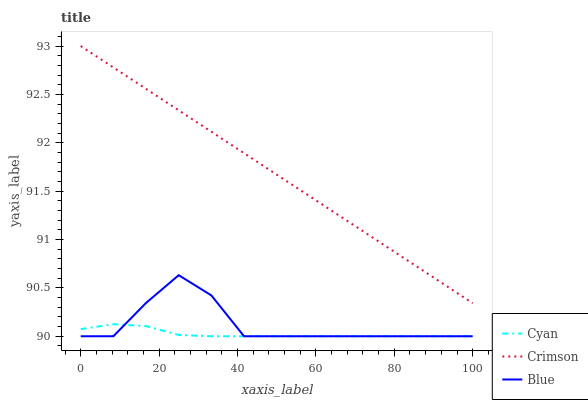Does Cyan have the minimum area under the curve?
Answer yes or no. Yes. Does Crimson have the maximum area under the curve?
Answer yes or no. Yes. Does Blue have the minimum area under the curve?
Answer yes or no. No. Does Blue have the maximum area under the curve?
Answer yes or no. No. Is Crimson the smoothest?
Answer yes or no. Yes. Is Blue the roughest?
Answer yes or no. Yes. Is Cyan the smoothest?
Answer yes or no. No. Is Cyan the roughest?
Answer yes or no. No. Does Cyan have the lowest value?
Answer yes or no. Yes. Does Crimson have the highest value?
Answer yes or no. Yes. Does Blue have the highest value?
Answer yes or no. No. Is Blue less than Crimson?
Answer yes or no. Yes. Is Crimson greater than Blue?
Answer yes or no. Yes. Does Cyan intersect Blue?
Answer yes or no. Yes. Is Cyan less than Blue?
Answer yes or no. No. Is Cyan greater than Blue?
Answer yes or no. No. Does Blue intersect Crimson?
Answer yes or no. No. 